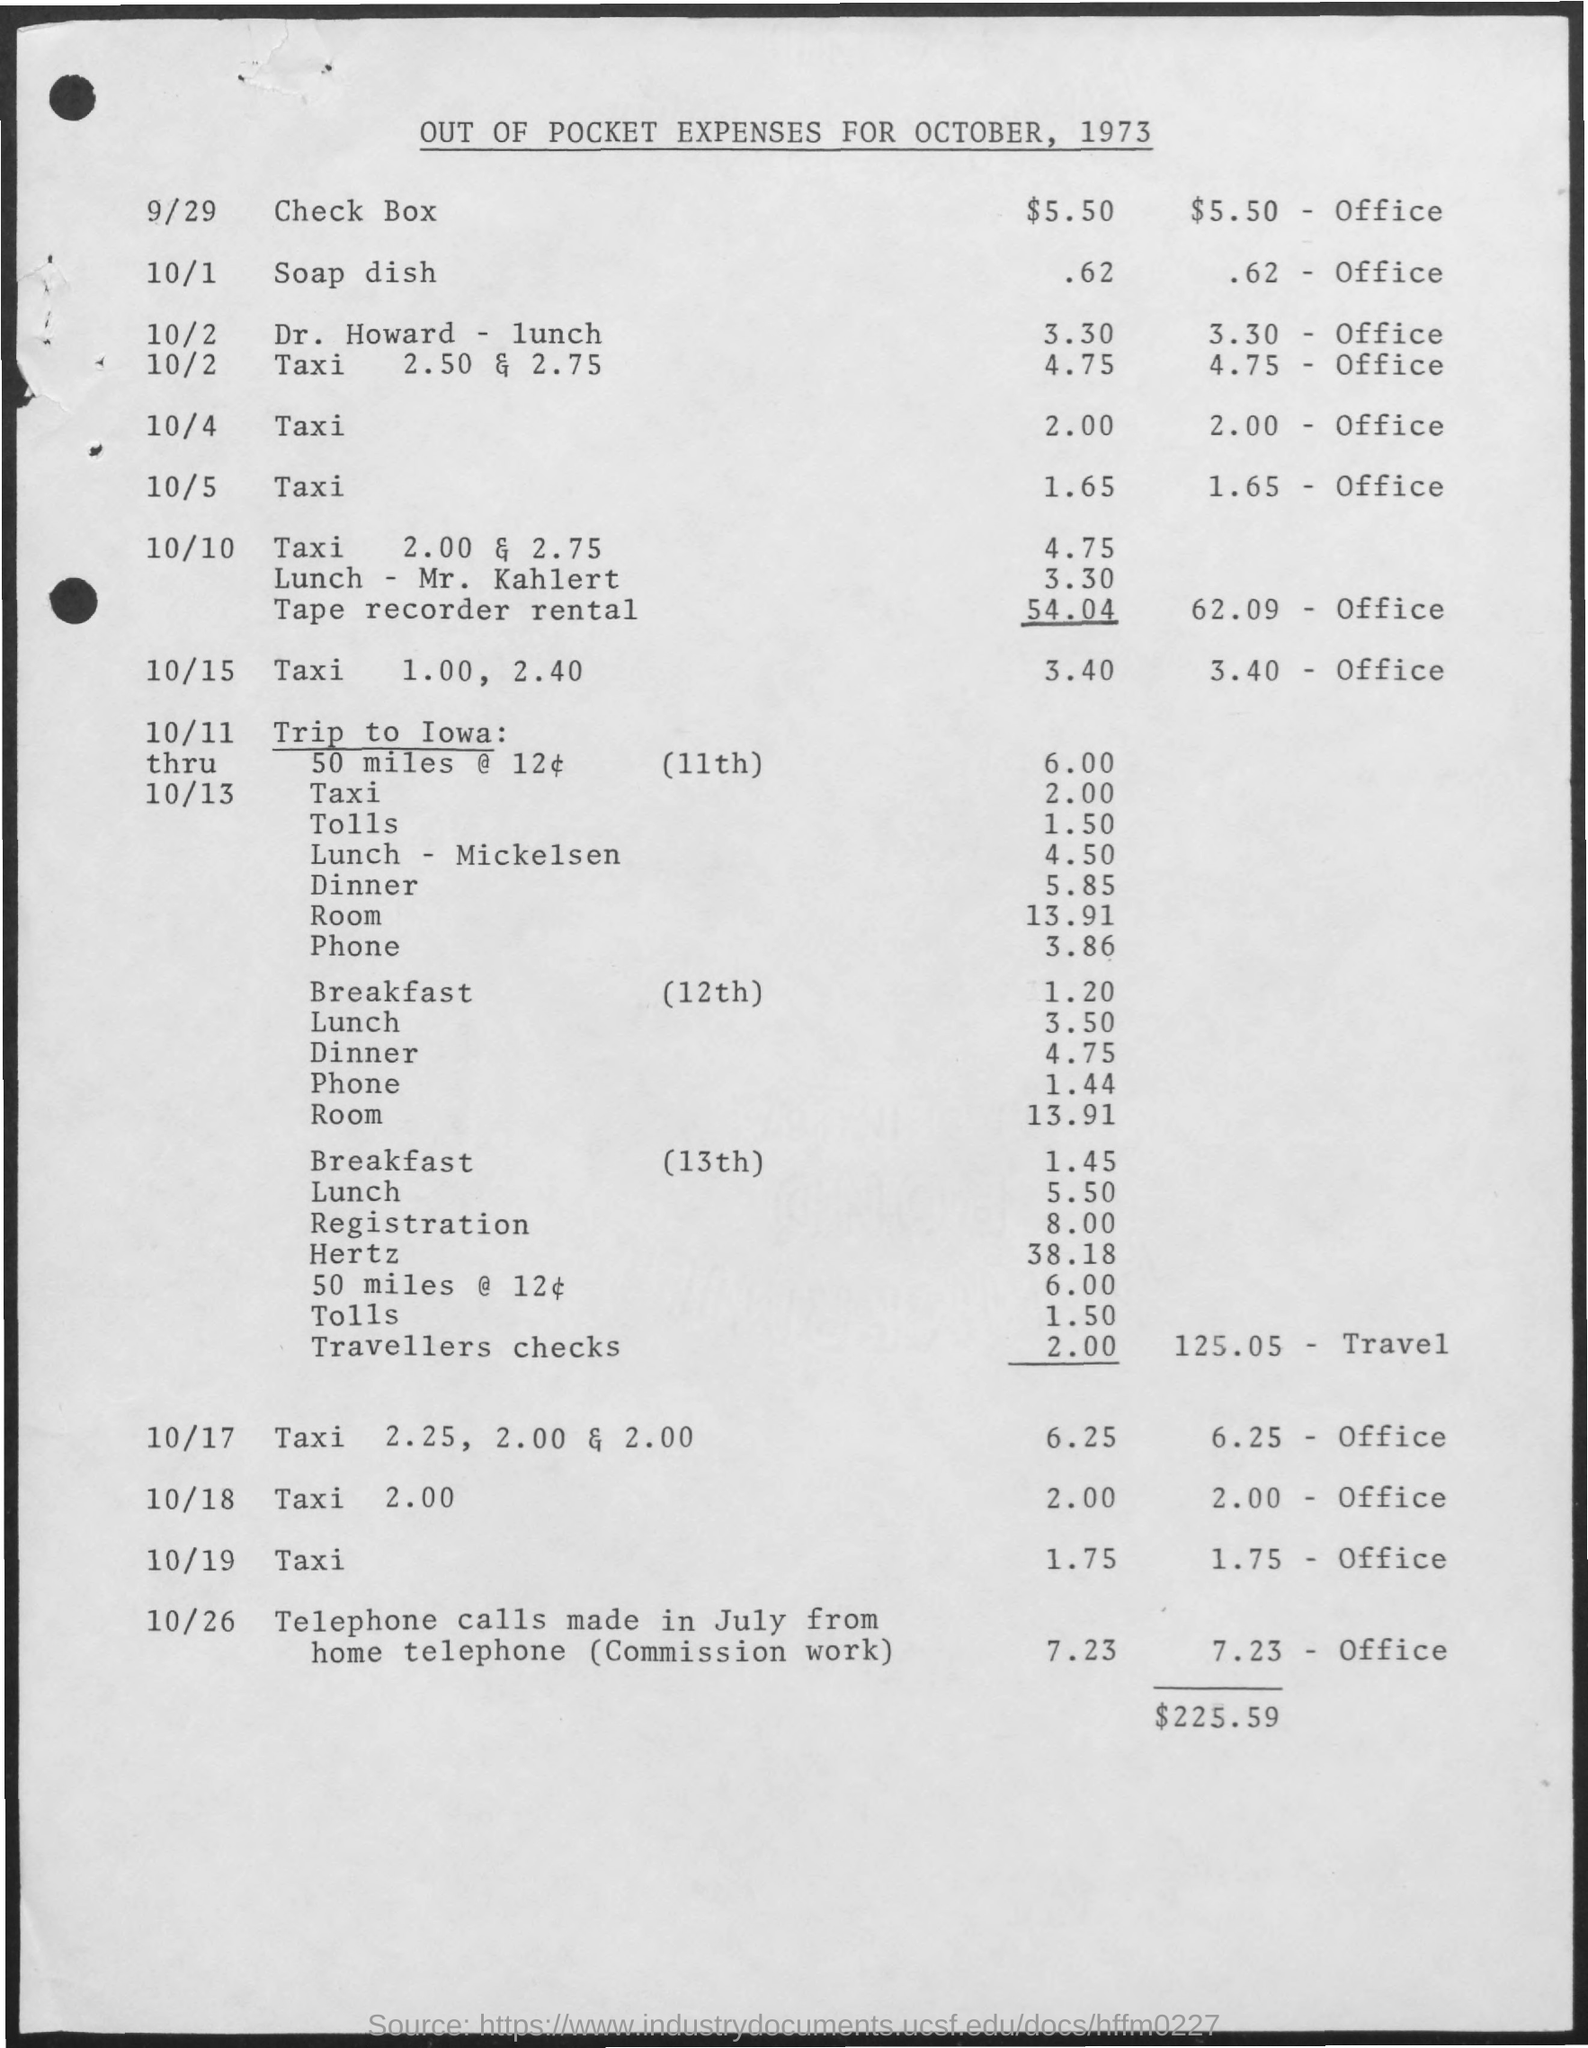Out of pocket expenses is calculated for which month and year ?
Offer a terse response. OCTOBER, 1973. How much amount is used for check box ?
Offer a terse response. $ 5.50. How much amount is spent for taxi on 10/19
Your answer should be compact. $1.75. What is the total amount spent ?
Ensure brevity in your answer.  $225.59. 